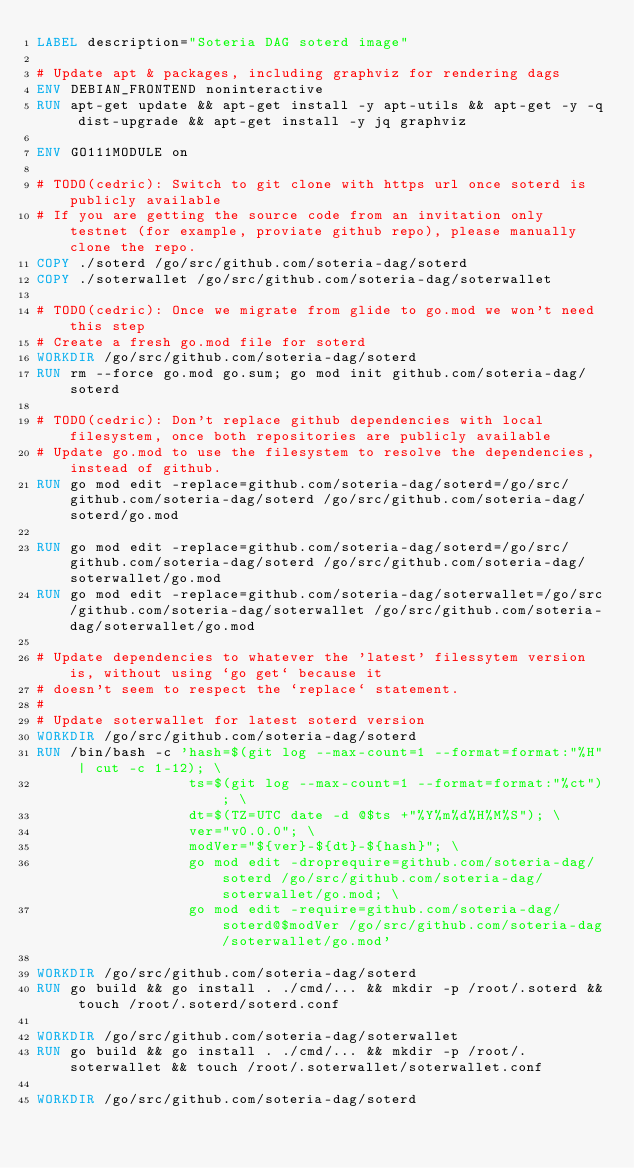<code> <loc_0><loc_0><loc_500><loc_500><_Dockerfile_>LABEL description="Soteria DAG soterd image"

# Update apt & packages, including graphviz for rendering dags
ENV DEBIAN_FRONTEND noninteractive
RUN apt-get update && apt-get install -y apt-utils && apt-get -y -q dist-upgrade && apt-get install -y jq graphviz

ENV GO111MODULE on

# TODO(cedric): Switch to git clone with https url once soterd is publicly available
# If you are getting the source code from an invitation only testnet (for example, proviate github repo), please manually clone the repo.
COPY ./soterd /go/src/github.com/soteria-dag/soterd
COPY ./soterwallet /go/src/github.com/soteria-dag/soterwallet

# TODO(cedric): Once we migrate from glide to go.mod we won't need this step
# Create a fresh go.mod file for soterd
WORKDIR /go/src/github.com/soteria-dag/soterd
RUN rm --force go.mod go.sum; go mod init github.com/soteria-dag/soterd

# TODO(cedric): Don't replace github dependencies with local filesystem, once both repositories are publicly available
# Update go.mod to use the filesystem to resolve the dependencies, instead of github.
RUN go mod edit -replace=github.com/soteria-dag/soterd=/go/src/github.com/soteria-dag/soterd /go/src/github.com/soteria-dag/soterd/go.mod

RUN go mod edit -replace=github.com/soteria-dag/soterd=/go/src/github.com/soteria-dag/soterd /go/src/github.com/soteria-dag/soterwallet/go.mod
RUN go mod edit -replace=github.com/soteria-dag/soterwallet=/go/src/github.com/soteria-dag/soterwallet /go/src/github.com/soteria-dag/soterwallet/go.mod

# Update dependencies to whatever the 'latest' filessytem version is, without using `go get` because it
# doesn't seem to respect the `replace` statement.
#
# Update soterwallet for latest soterd version
WORKDIR /go/src/github.com/soteria-dag/soterd
RUN /bin/bash -c 'hash=$(git log --max-count=1 --format=format:"%H" | cut -c 1-12); \
                  ts=$(git log --max-count=1 --format=format:"%ct"); \
                  dt=$(TZ=UTC date -d @$ts +"%Y%m%d%H%M%S"); \
                  ver="v0.0.0"; \
                  modVer="${ver}-${dt}-${hash}"; \
                  go mod edit -droprequire=github.com/soteria-dag/soterd /go/src/github.com/soteria-dag/soterwallet/go.mod; \
                  go mod edit -require=github.com/soteria-dag/soterd@$modVer /go/src/github.com/soteria-dag/soterwallet/go.mod'

WORKDIR /go/src/github.com/soteria-dag/soterd
RUN go build && go install . ./cmd/... && mkdir -p /root/.soterd && touch /root/.soterd/soterd.conf

WORKDIR /go/src/github.com/soteria-dag/soterwallet
RUN go build && go install . ./cmd/... && mkdir -p /root/.soterwallet && touch /root/.soterwallet/soterwallet.conf

WORKDIR /go/src/github.com/soteria-dag/soterd
</code> 